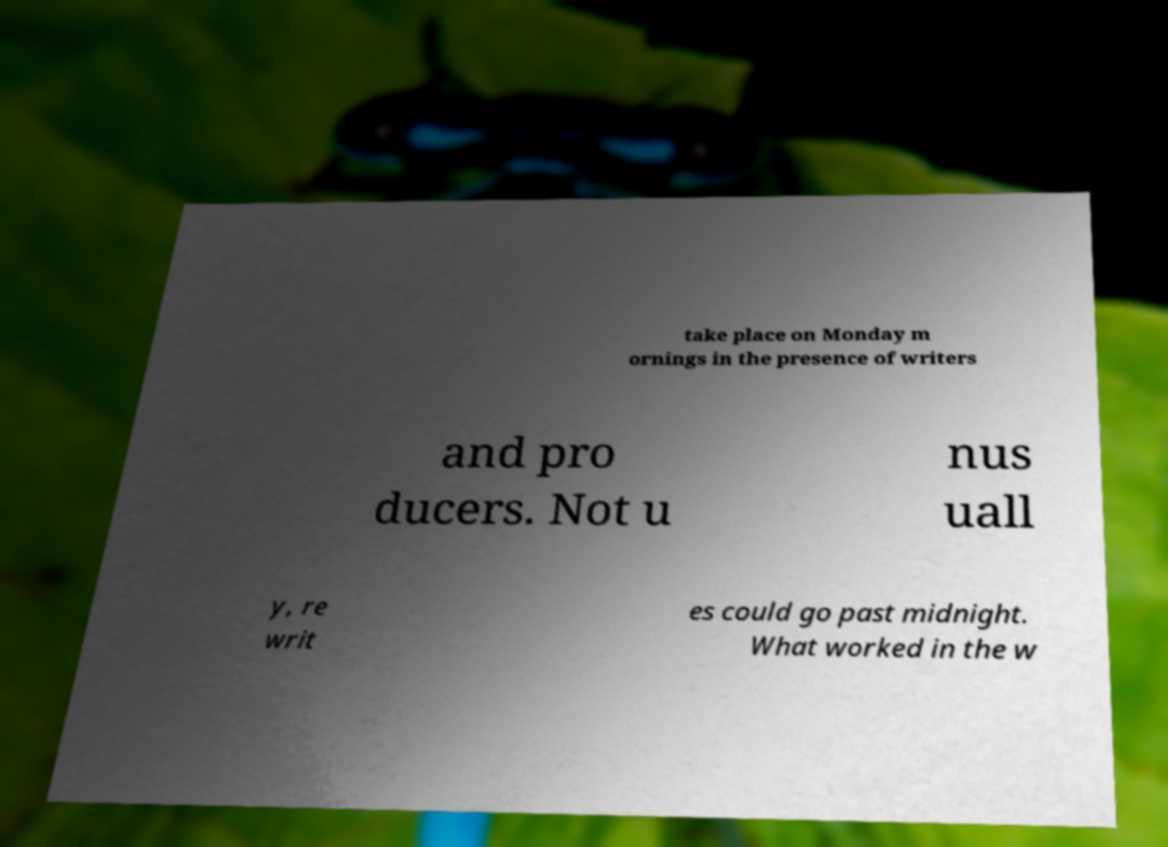Can you accurately transcribe the text from the provided image for me? take place on Monday m ornings in the presence of writers and pro ducers. Not u nus uall y, re writ es could go past midnight. What worked in the w 